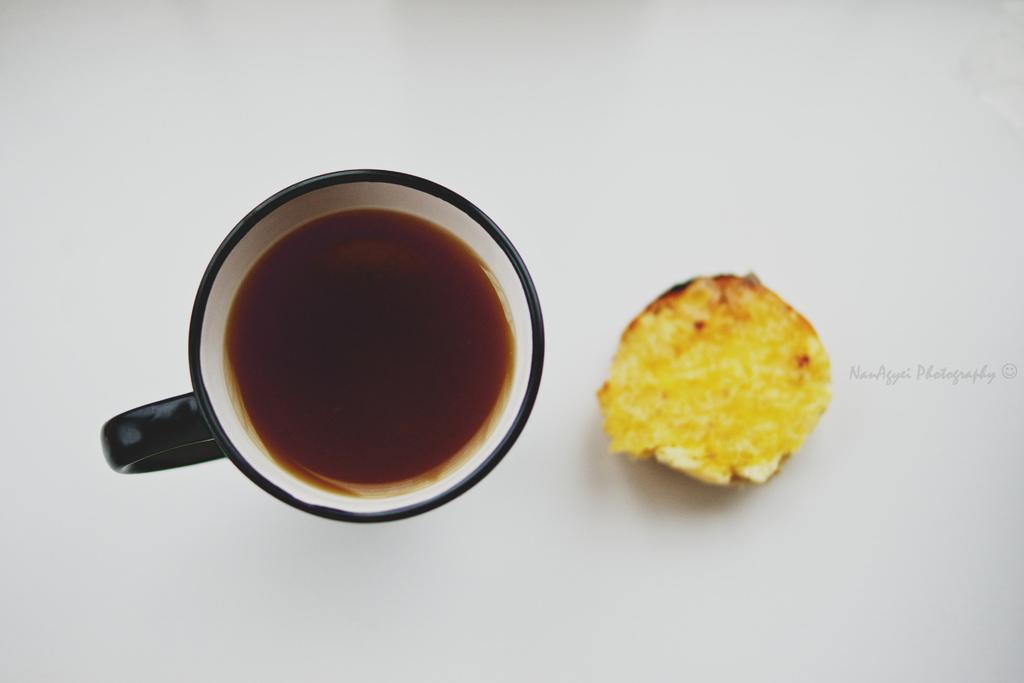Could you give a brief overview of what you see in this image? There is a white surface. On that there is a cup with brown color liquid. Also there is a yellow color food item. 